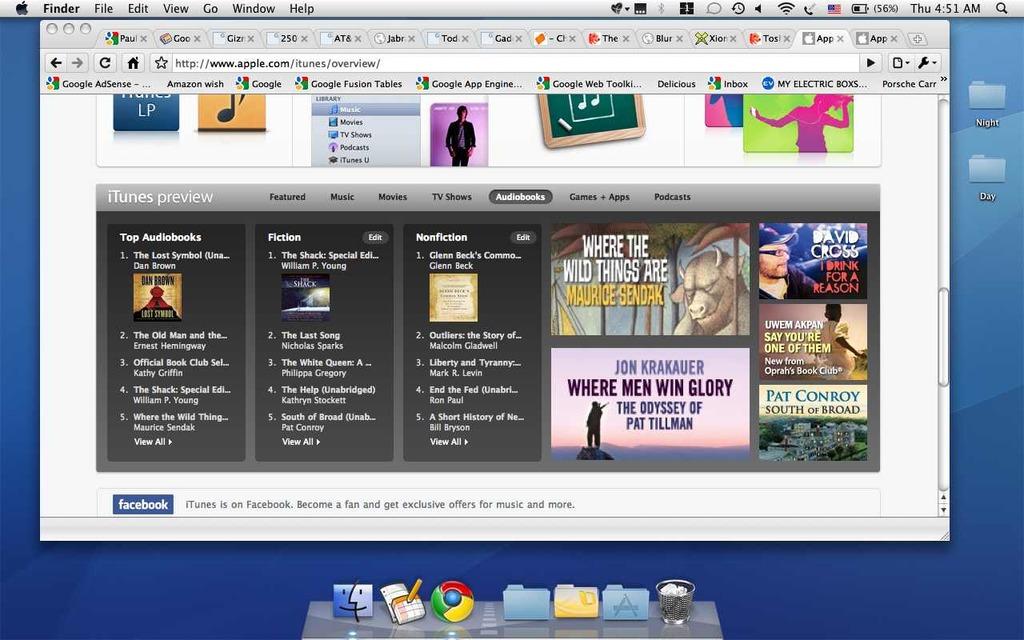Who wrote where men win glory: the odyssey of pat tillman?
Make the answer very short. Jon krakauer. Are these on itunes?
Keep it short and to the point. Yes. 